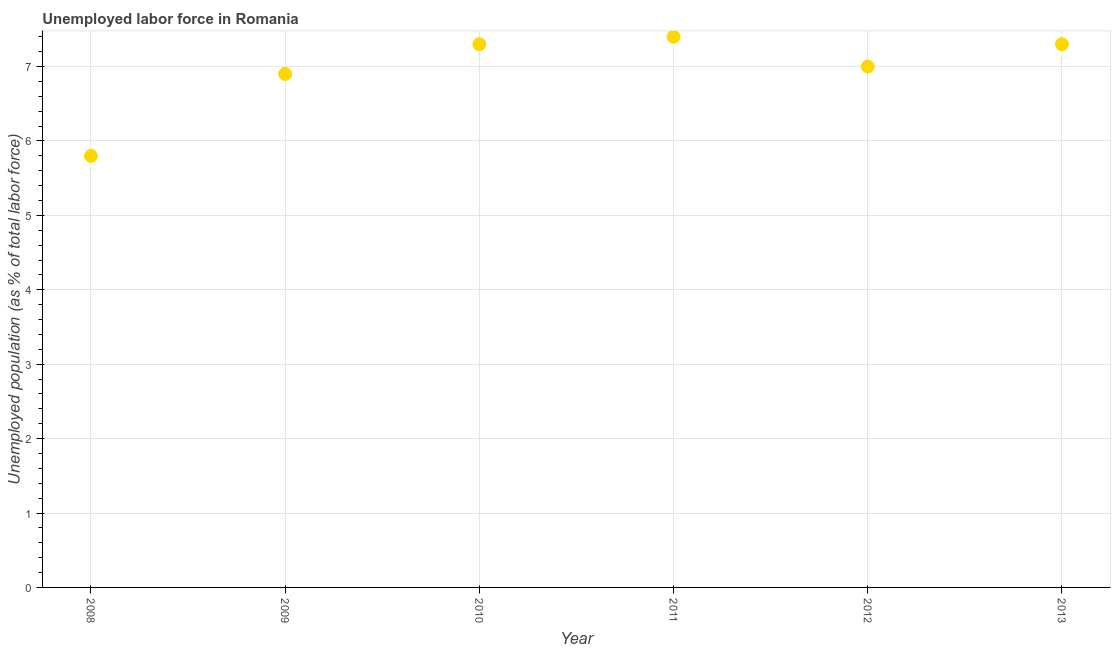What is the total unemployed population in 2009?
Provide a short and direct response. 6.9. Across all years, what is the maximum total unemployed population?
Your answer should be compact. 7.4. Across all years, what is the minimum total unemployed population?
Provide a short and direct response. 5.8. What is the sum of the total unemployed population?
Keep it short and to the point. 41.7. What is the difference between the total unemployed population in 2011 and 2012?
Make the answer very short. 0.4. What is the average total unemployed population per year?
Offer a very short reply. 6.95. What is the median total unemployed population?
Give a very brief answer. 7.15. Do a majority of the years between 2011 and 2013 (inclusive) have total unemployed population greater than 4.8 %?
Keep it short and to the point. Yes. What is the ratio of the total unemployed population in 2009 to that in 2010?
Your response must be concise. 0.95. Is the total unemployed population in 2008 less than that in 2012?
Your answer should be compact. Yes. What is the difference between the highest and the second highest total unemployed population?
Give a very brief answer. 0.1. What is the difference between the highest and the lowest total unemployed population?
Provide a short and direct response. 1.6. In how many years, is the total unemployed population greater than the average total unemployed population taken over all years?
Provide a short and direct response. 4. How many dotlines are there?
Make the answer very short. 1. How many years are there in the graph?
Provide a succinct answer. 6. What is the title of the graph?
Give a very brief answer. Unemployed labor force in Romania. What is the label or title of the Y-axis?
Keep it short and to the point. Unemployed population (as % of total labor force). What is the Unemployed population (as % of total labor force) in 2008?
Provide a short and direct response. 5.8. What is the Unemployed population (as % of total labor force) in 2009?
Keep it short and to the point. 6.9. What is the Unemployed population (as % of total labor force) in 2010?
Keep it short and to the point. 7.3. What is the Unemployed population (as % of total labor force) in 2011?
Your answer should be compact. 7.4. What is the Unemployed population (as % of total labor force) in 2012?
Your answer should be compact. 7. What is the Unemployed population (as % of total labor force) in 2013?
Your answer should be compact. 7.3. What is the difference between the Unemployed population (as % of total labor force) in 2008 and 2009?
Your answer should be very brief. -1.1. What is the difference between the Unemployed population (as % of total labor force) in 2008 and 2010?
Provide a succinct answer. -1.5. What is the difference between the Unemployed population (as % of total labor force) in 2009 and 2010?
Provide a succinct answer. -0.4. What is the difference between the Unemployed population (as % of total labor force) in 2009 and 2011?
Keep it short and to the point. -0.5. What is the difference between the Unemployed population (as % of total labor force) in 2010 and 2012?
Your answer should be very brief. 0.3. What is the difference between the Unemployed population (as % of total labor force) in 2012 and 2013?
Provide a succinct answer. -0.3. What is the ratio of the Unemployed population (as % of total labor force) in 2008 to that in 2009?
Offer a terse response. 0.84. What is the ratio of the Unemployed population (as % of total labor force) in 2008 to that in 2010?
Provide a succinct answer. 0.8. What is the ratio of the Unemployed population (as % of total labor force) in 2008 to that in 2011?
Your response must be concise. 0.78. What is the ratio of the Unemployed population (as % of total labor force) in 2008 to that in 2012?
Offer a terse response. 0.83. What is the ratio of the Unemployed population (as % of total labor force) in 2008 to that in 2013?
Make the answer very short. 0.8. What is the ratio of the Unemployed population (as % of total labor force) in 2009 to that in 2010?
Provide a succinct answer. 0.94. What is the ratio of the Unemployed population (as % of total labor force) in 2009 to that in 2011?
Your answer should be very brief. 0.93. What is the ratio of the Unemployed population (as % of total labor force) in 2009 to that in 2012?
Make the answer very short. 0.99. What is the ratio of the Unemployed population (as % of total labor force) in 2009 to that in 2013?
Ensure brevity in your answer.  0.94. What is the ratio of the Unemployed population (as % of total labor force) in 2010 to that in 2011?
Provide a succinct answer. 0.99. What is the ratio of the Unemployed population (as % of total labor force) in 2010 to that in 2012?
Offer a very short reply. 1.04. What is the ratio of the Unemployed population (as % of total labor force) in 2011 to that in 2012?
Provide a short and direct response. 1.06. 